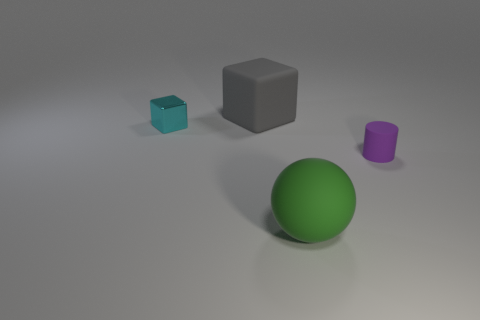Add 3 large cyan blocks. How many objects exist? 7 Subtract all spheres. How many objects are left? 3 Subtract 0 red balls. How many objects are left? 4 Subtract all gray matte cubes. Subtract all large gray matte blocks. How many objects are left? 2 Add 2 tiny cyan cubes. How many tiny cyan cubes are left? 3 Add 1 tiny purple cylinders. How many tiny purple cylinders exist? 2 